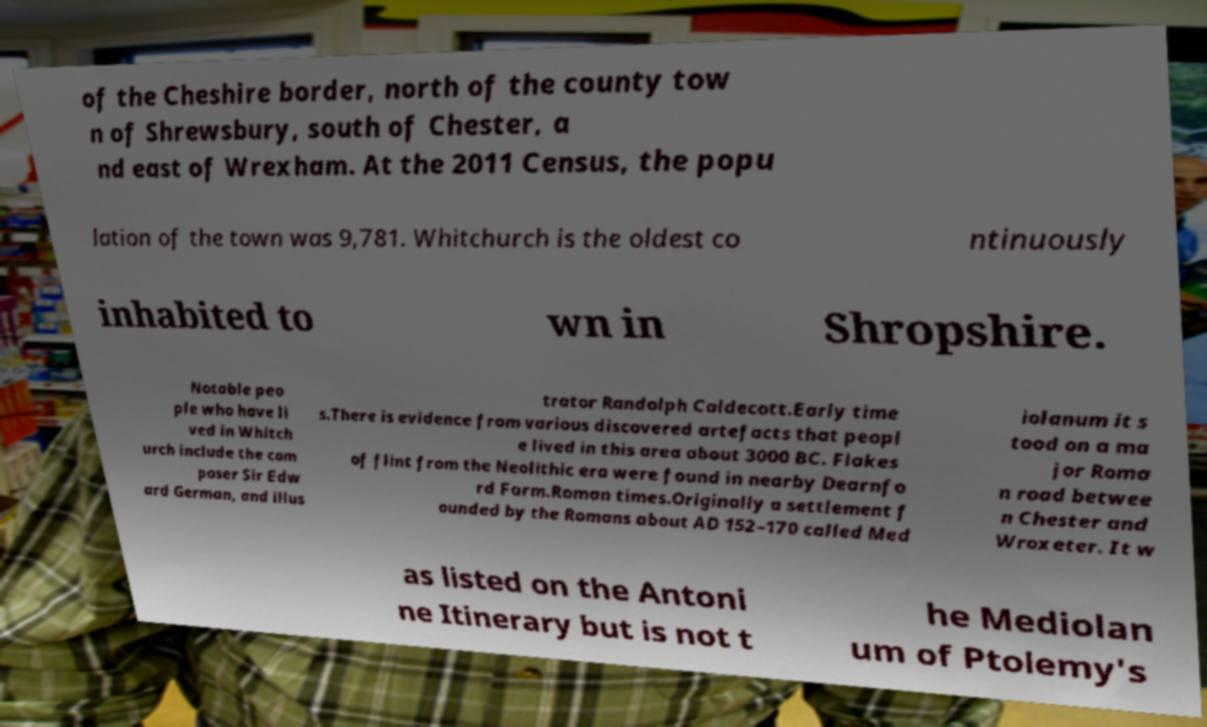There's text embedded in this image that I need extracted. Can you transcribe it verbatim? of the Cheshire border, north of the county tow n of Shrewsbury, south of Chester, a nd east of Wrexham. At the 2011 Census, the popu lation of the town was 9,781. Whitchurch is the oldest co ntinuously inhabited to wn in Shropshire. Notable peo ple who have li ved in Whitch urch include the com poser Sir Edw ard German, and illus trator Randolph Caldecott.Early time s.There is evidence from various discovered artefacts that peopl e lived in this area about 3000 BC. Flakes of flint from the Neolithic era were found in nearby Dearnfo rd Farm.Roman times.Originally a settlement f ounded by the Romans about AD 152–170 called Med iolanum it s tood on a ma jor Roma n road betwee n Chester and Wroxeter. It w as listed on the Antoni ne Itinerary but is not t he Mediolan um of Ptolemy's 